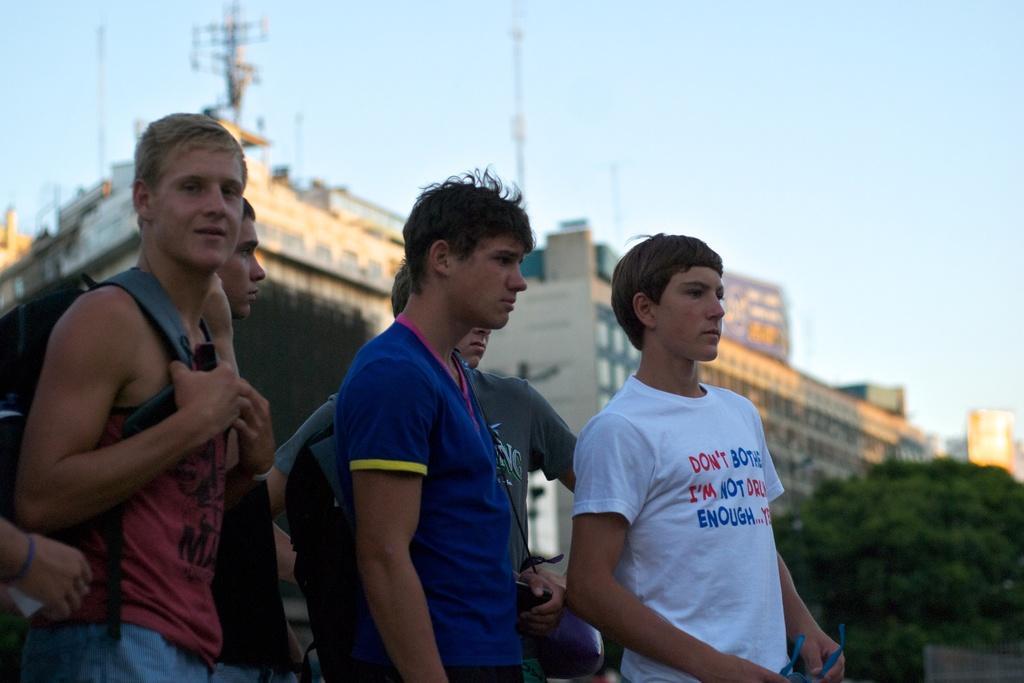In one or two sentences, can you explain what this image depicts? In this image, we can see people and some are wearing bags and one of them is holding glasses. In the background, there are buildings and we can see trees and poles. At the top, there is sky. 